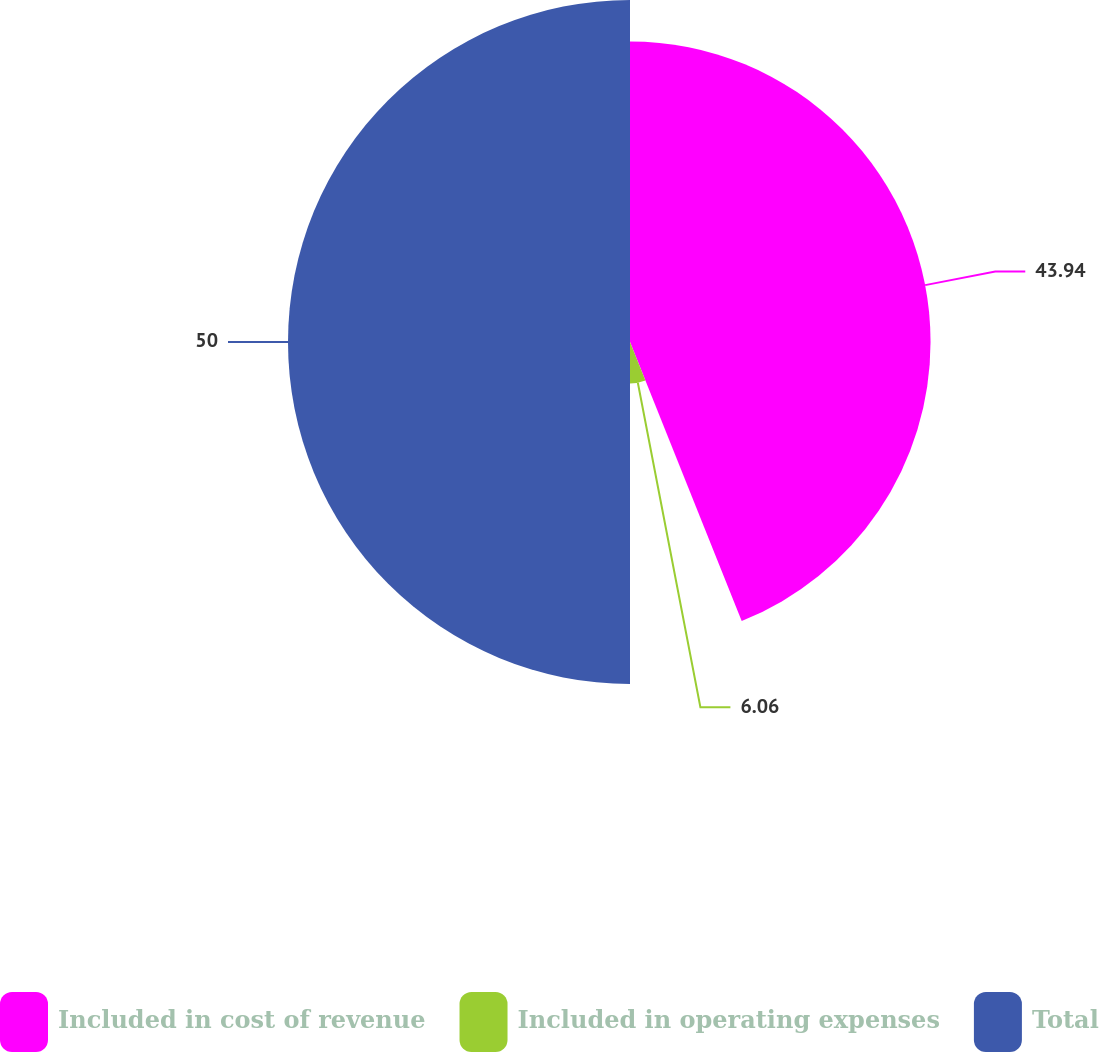Convert chart to OTSL. <chart><loc_0><loc_0><loc_500><loc_500><pie_chart><fcel>Included in cost of revenue<fcel>Included in operating expenses<fcel>Total<nl><fcel>43.94%<fcel>6.06%<fcel>50.0%<nl></chart> 